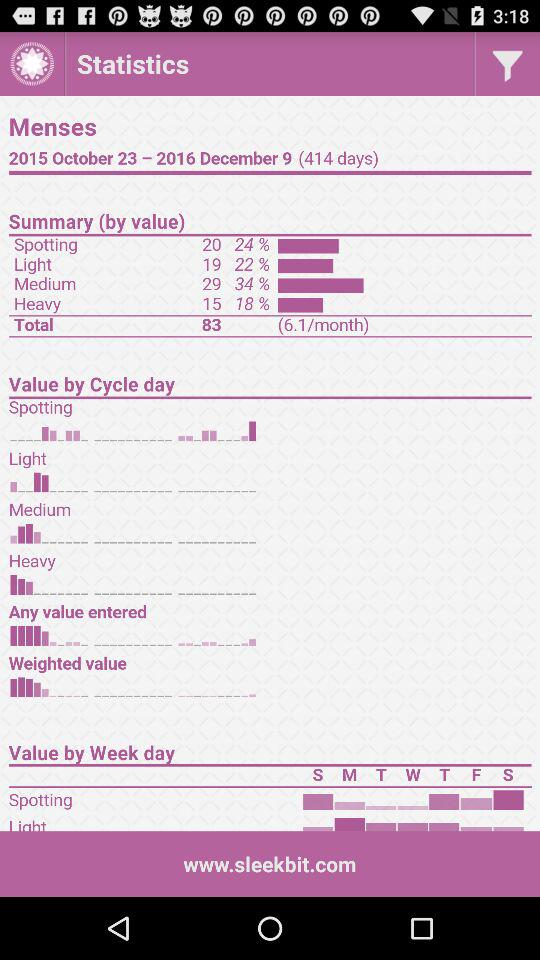What is the total number of days in the statistics?
Answer the question using a single word or phrase. 414 days 